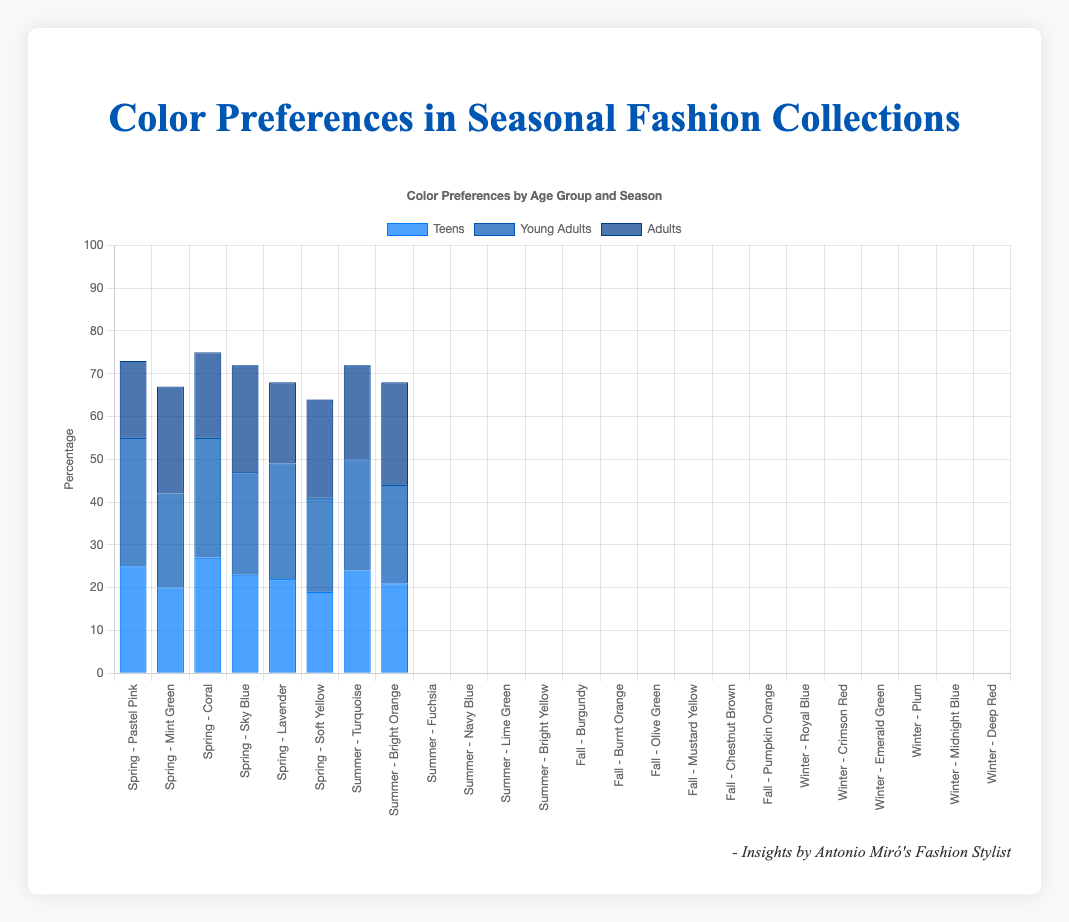Which season's preferred color for adults has the highest percentage? To find the answer, locate the bars representing the preferred colors for adults in each season, then compare their heights to determine which is the tallest. The highest percentage for adults occurs in the summer with "Bright Yellow" and "Soft Yellow" in spring. Both with a percentage of 25%.
Answer: Summer and Spring What is the total percentage of teens' preferred colors in winter? To find this, add up the percentages for teens in the winter season: "Royal Blue" (24%) and "Crimson Red" (21%). So, 24% + 21% equals 45%.
Answer: 45% Which age group has the highest preference percentage for a single color in the spring? In the spring, compare the percentages of the preferred colors across age groups: Teens ("Pastel Pink" 25%, "Mint Green" 20%), Young Adults ("Coral" 30%, "Sky Blue" 22%), and Adults ("Lavender" 18%, "Soft Yellow" 25%). The highest percentage is for "Coral" by Young Adults at 30%.
Answer: Young Adults Which color is the least preferred by young adults in fall? Examine the bars corresponding to young adults in the fall season: "Olive Green" (27%) and "Mustard Yellow" (22%). The least preferred color is "Mustard Yellow" at 22%.
Answer: Mustard Yellow How does the preference for “Pastel Pink” in spring compare between teens and adults? Observe the bar heights for "Pastel Pink" in spring for teens (25%) and for adults (not listed). Since adults don’t have "Pastel Pink" listed, the comparison shows that teens prefer it and adults do not.
Answer: Teens prefer it, adults don't What is the average percentage preference for the listed colors by adults in each season? To find the average, add up the percentages for adults in each season and divide by the number of colors: Spring (Lavender 18%, Soft Yellow 25%), Summer (Lime Green 20%, Bright Yellow 25%), Fall (Chestnut Brown 19%, Pumpkin Orange 23%), Winter (Midnight Blue 22%, Deep Red 24%). The sum is 18 + 25 + 20 + 25 + 19 + 23 + 22 + 24 = 176, and there are 8 colors. Thus, the average is 176/8 = 22%.
Answer: 22% Which season shows the highest overall percentage of preferred colors for teens? Sum the percentages of the preferred colors for teens in each season: Spring (Pastel Pink 25%, Mint Green 20%), Summer (Turquoise 27%, Bright Orange 23%), Fall (Burgundy 22%, Burnt Orange 19%), Winter (Royal Blue 24%, Crimson Red 21%). Then compare the totals: Spring (45%), Summer (50%), Fall (41%), Winter (45%). Summer has the highest total at 50%.
Answer: Summer Compare the preference between "Emerald Green" and "Plum" in winter for young adults. Which is more preferred and by how much? Check the bar heights for "Emerald Green" (26%) and "Plum" (23%) for young adults in winter. "Emerald Green" is more preferred. The difference is 26% - 23% = 3%.
Answer: Emerald Green, by 3% What color preference is highest for teens during summer? Identify the preferred colors and their percentages for teens in the summer: "Turquoise" (27%) and "Bright Orange" (23%). The highest preferred color is "Turquoise" at 27%.
Answer: Turquoise Comparing the percentage preferences for "Sky Blue" in spring and "Navy Blue" in summer for young adults, which is higher? Locate the percentages for "Sky Blue" (22%) in spring and "Navy Blue" (24%) in summer for young adults. "Navy Blue" at 24% is higher.
Answer: Navy Blue 